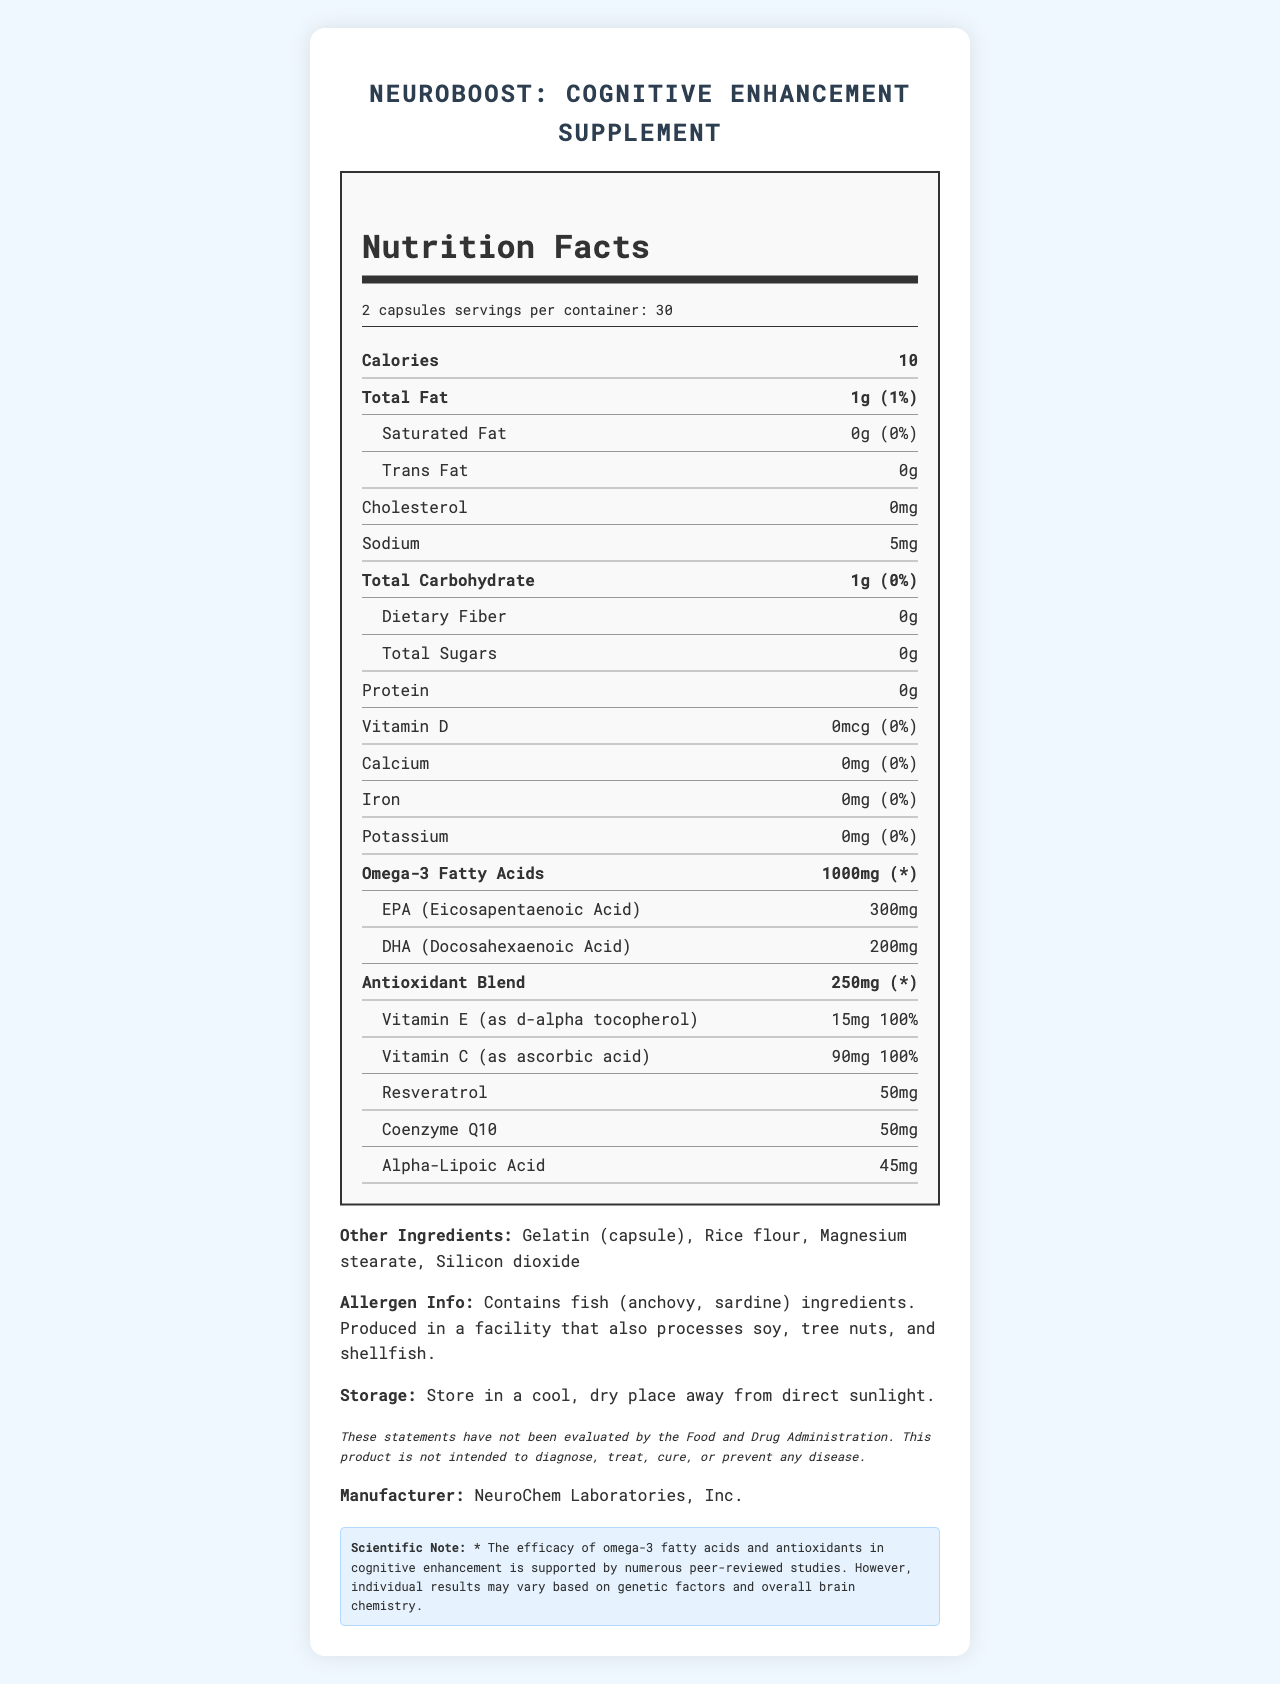what is the serving size? The serving size is listed at the top of the Nutrition Facts label as "2 capsules".
Answer: 2 capsules how many servings per container? The number of servings per container is indicated at the top of the Nutrition Facts label as "30".
Answer: 30 how many calories are in one serving? The calorie content per serving is listed as "10" in bold under the "Calories" section.
Answer: 10 what is the total amount of omega-3 fatty acids per serving? The total amount of omega-3 fatty acids per serving is specified as "1000mg" in bold under the Omega-3 Fatty Acids section.
Answer: 1000mg name the components of the antioxidant blend and their amounts The components and amounts of the antioxidant blend are listed under the Antioxidant Blend section with their respective amounts next to their names.
Answer: Vitamin E: 15mg, Vitamin C: 90mg, Resveratrol: 50mg, Coenzyme Q10: 50mg, Alpha-Lipoic Acid: 45mg which of the following ingredients is NOT part of the other ingredients? A. Gelatin B. Soy C. Rice flour D. Magnesium stearate Soy is not mentioned in the list of other ingredients, which includes Gelatin, Rice flour, Magnesium stearate, and Silicon dioxide.
Answer: B how much Vitamin C is in a serving, and what percentage of the daily value does this represent? A. 15mg, 100% B. 90mg, 100% C. 50mg, 50% D. 45mg, 50% The amount of Vitamin C is 90mg, representing 100% of the daily value, as indicated under the antioxidant components.
Answer: B does this supplement contain any ingredients derived from fish? The allergen info mentions that the supplement contains fish ingredients from anchovy and sardine.
Answer: Yes describe the main points covered in the document. The document details the nutritional content, ingredients, and other relevant information about the NeuroBoost supplement, including the amounts and percentages of various nutrients and components like omega-3 fatty acids and antioxidants.
Answer: The document provides the Nutrition Facts for NeuroBoost: Cognitive Enhancement Supplement. It includes serving size, servings per container, calories, fats, cholesterol, sodium, carbohydrates, protein, vitamins, minerals, omega-3 fatty acids, and an antioxidant blend. Additional information includes other ingredients, allergen info, storage instructions, a disclaimer, and manufacturer details. how many mg of potassium are in one serving? The amount of potassium per serving is listed as "0mg" under the Potassium section.
Answer: 0mg are there any daily values listed for omega-3 fatty acids and antioxidant blend? The daily values for omega-3 fatty acids and the antioxidant blend are marked with an asterisk (*) indicating they are not specified.
Answer: No can I find information about the exact percentage of fish oil content? The document does not provide specific details on the percentage of fish oil content; it only lists the ingredients and amounts.
Answer: Not enough information 